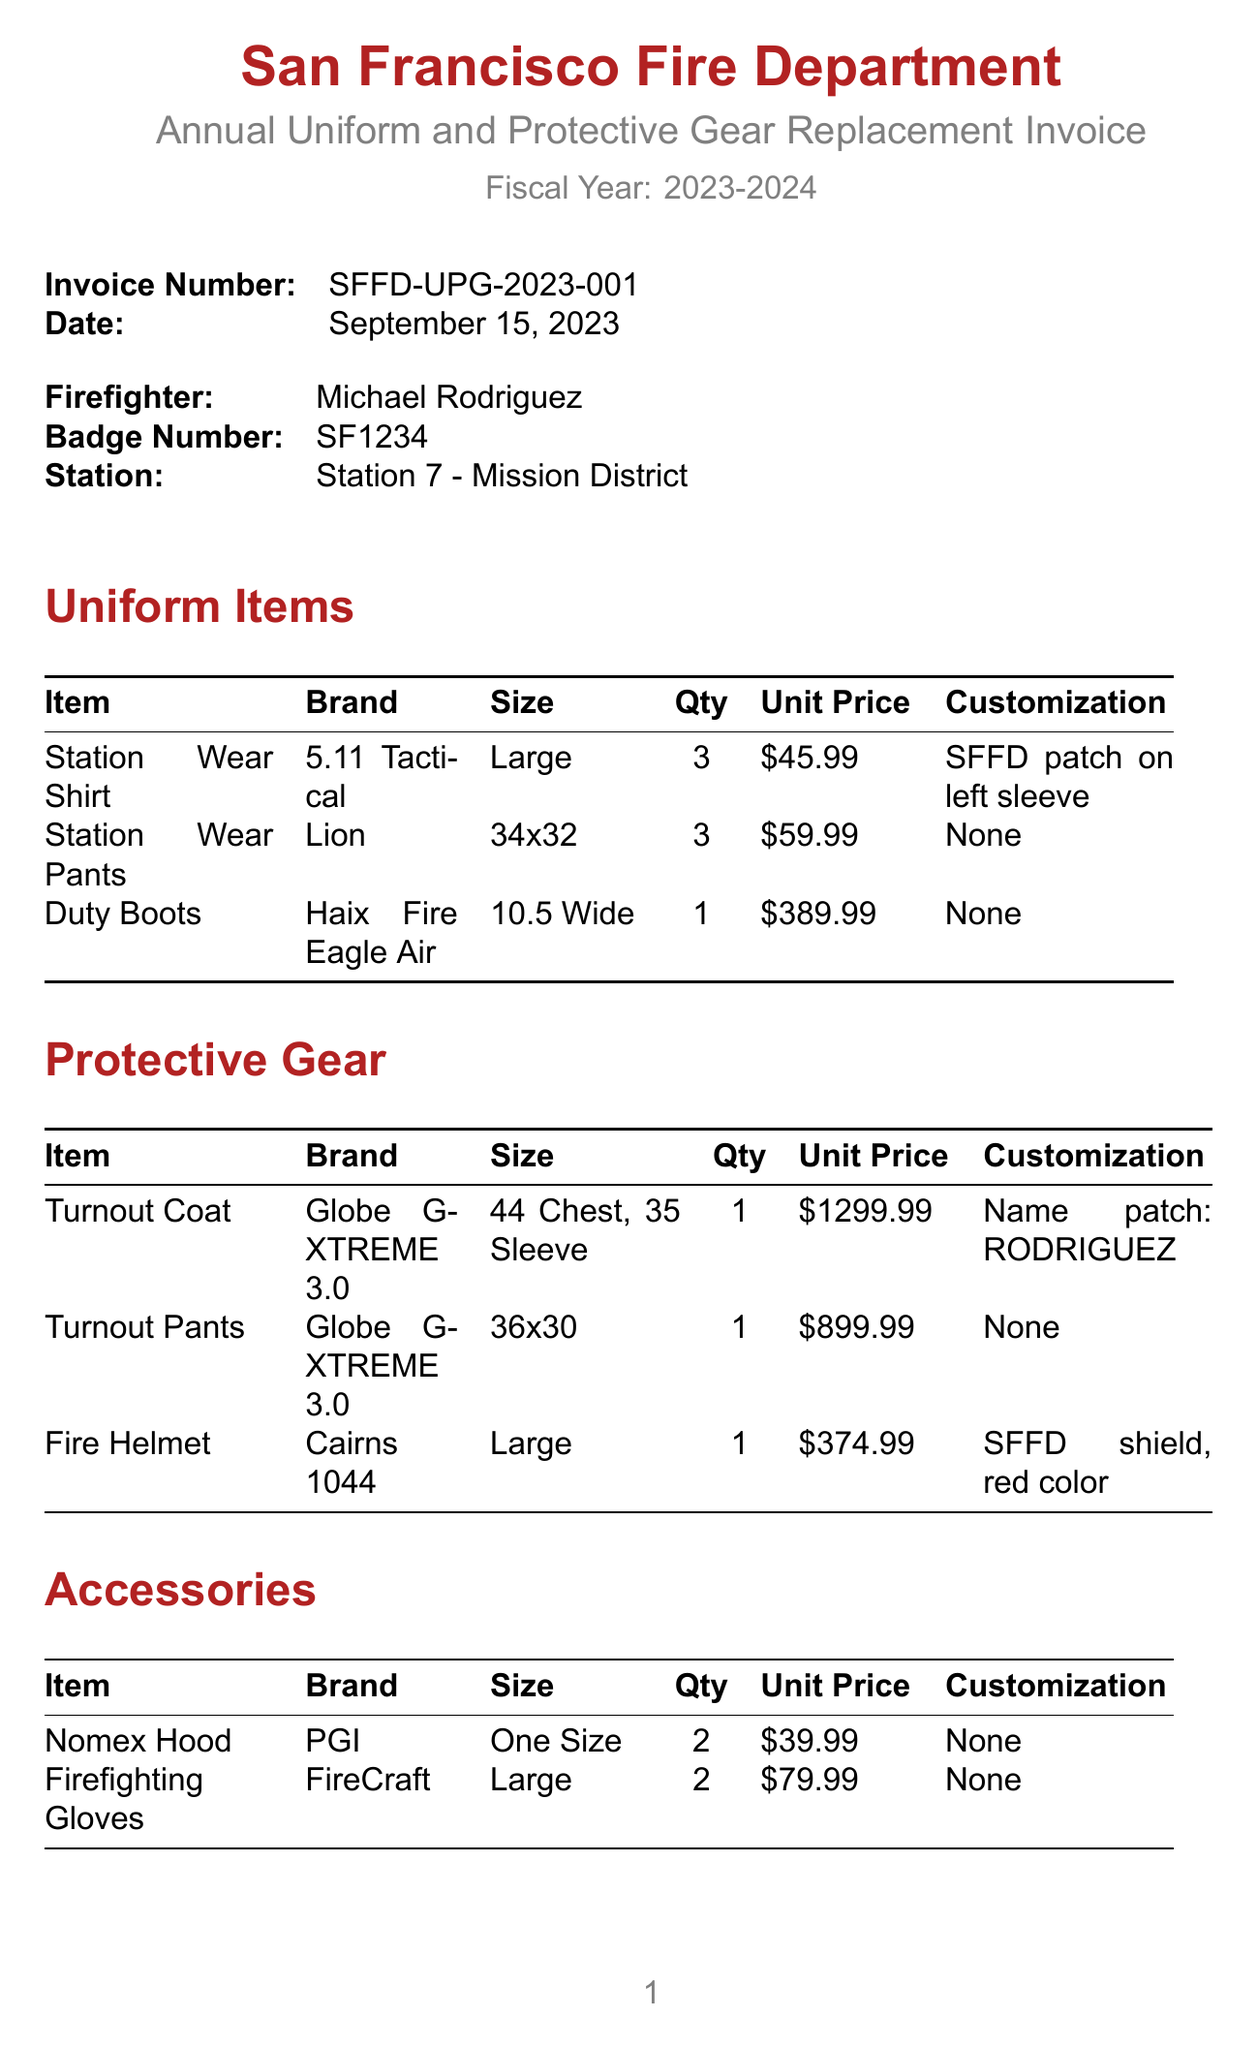what is the department name? The department name is located in the invoice header section of the document.
Answer: San Francisco Fire Department what is the invoice number? The invoice number is specified in the invoice header section of the document.
Answer: SFFD-UPG-2023-001 who is the firefighter mentioned in the invoice? The firefighter's name is provided in the firefighter details section.
Answer: Michael Rodriguez how many Station Wear Shirts are ordered? The quantity of Station Wear Shirts is detailed under the uniform items section.
Answer: 3 what is the total cost of the invoice? The total cost is prominently stated towards the end of the invoice document.
Answer: 3720.87 what is the size of the Duty Boots? The size of the Duty Boots is included in the uniform items section of the document.
Answer: 10.5 Wide how many items are listed under Protective Gear? The number of items can be counted from the protective gear section of the invoice.
Answer: 3 what customization is requested for the Turnout Coat? The customization for the Turnout Coat is mentioned in the protective gear section.
Answer: Name patch: RODRIGUEZ what is the payment term indicated in the invoice? The payment terms are listed in the document, providing payment expectations.
Answer: Net 30 